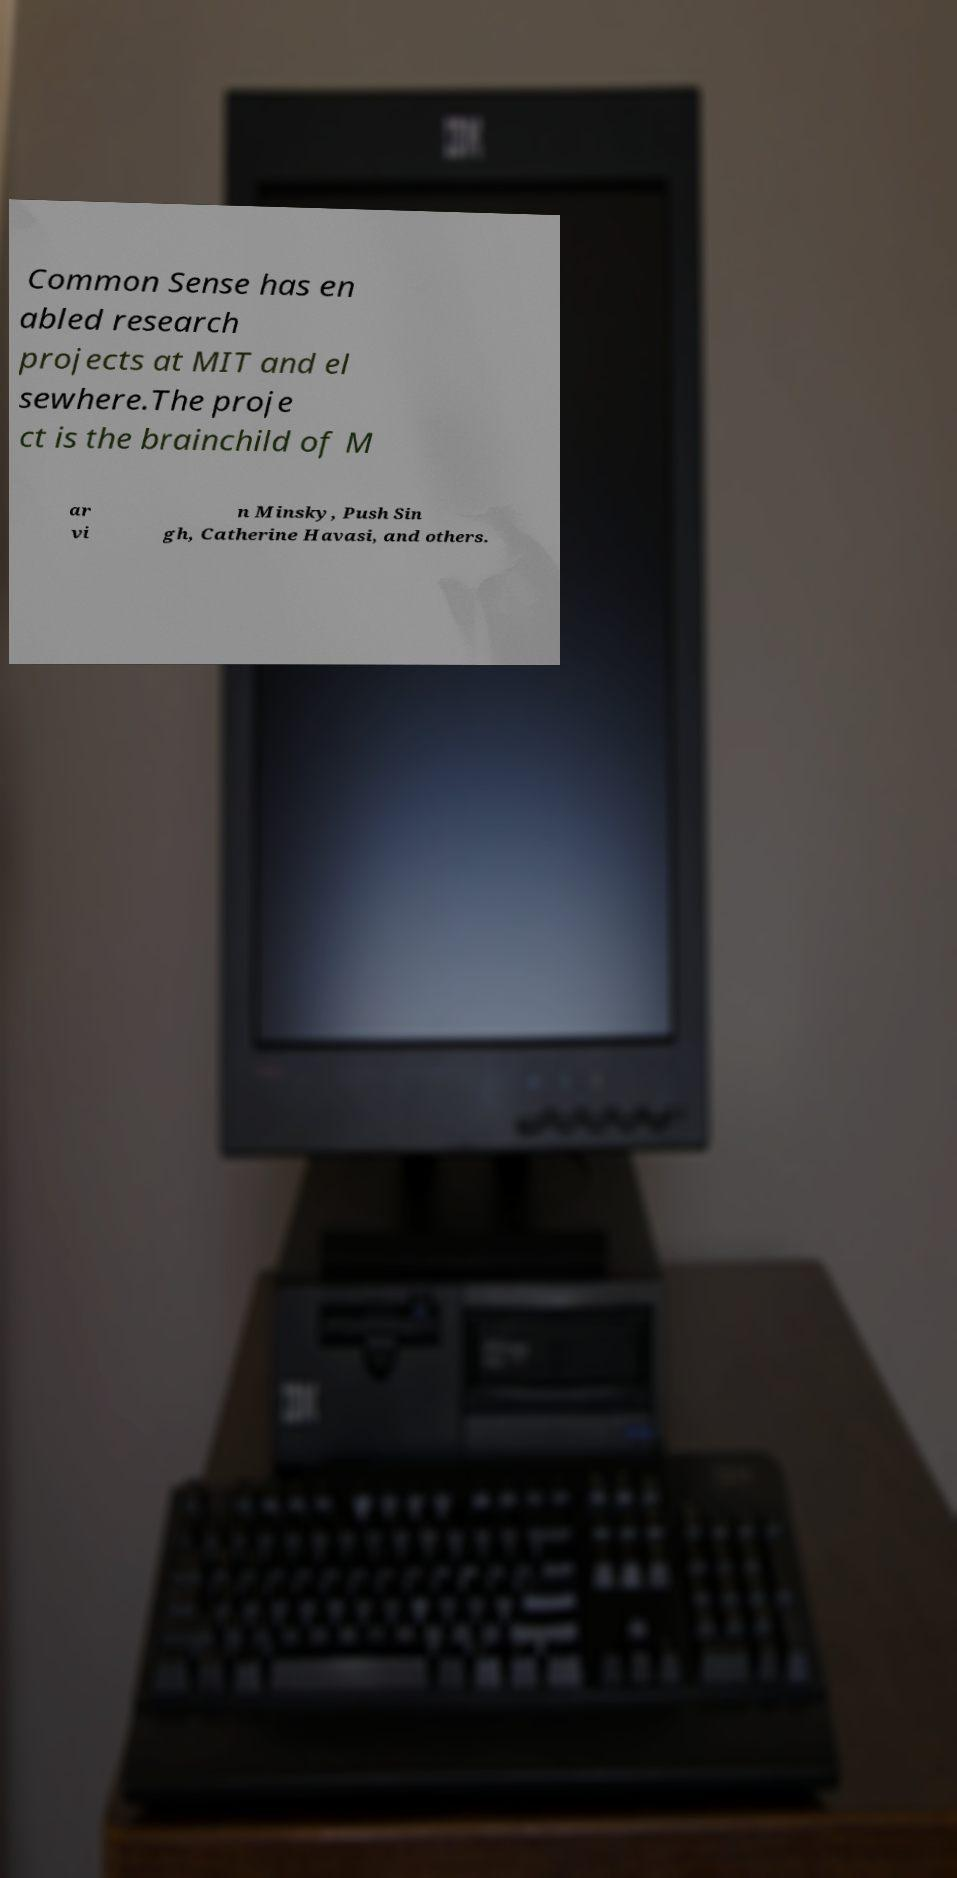For documentation purposes, I need the text within this image transcribed. Could you provide that? Common Sense has en abled research projects at MIT and el sewhere.The proje ct is the brainchild of M ar vi n Minsky, Push Sin gh, Catherine Havasi, and others. 